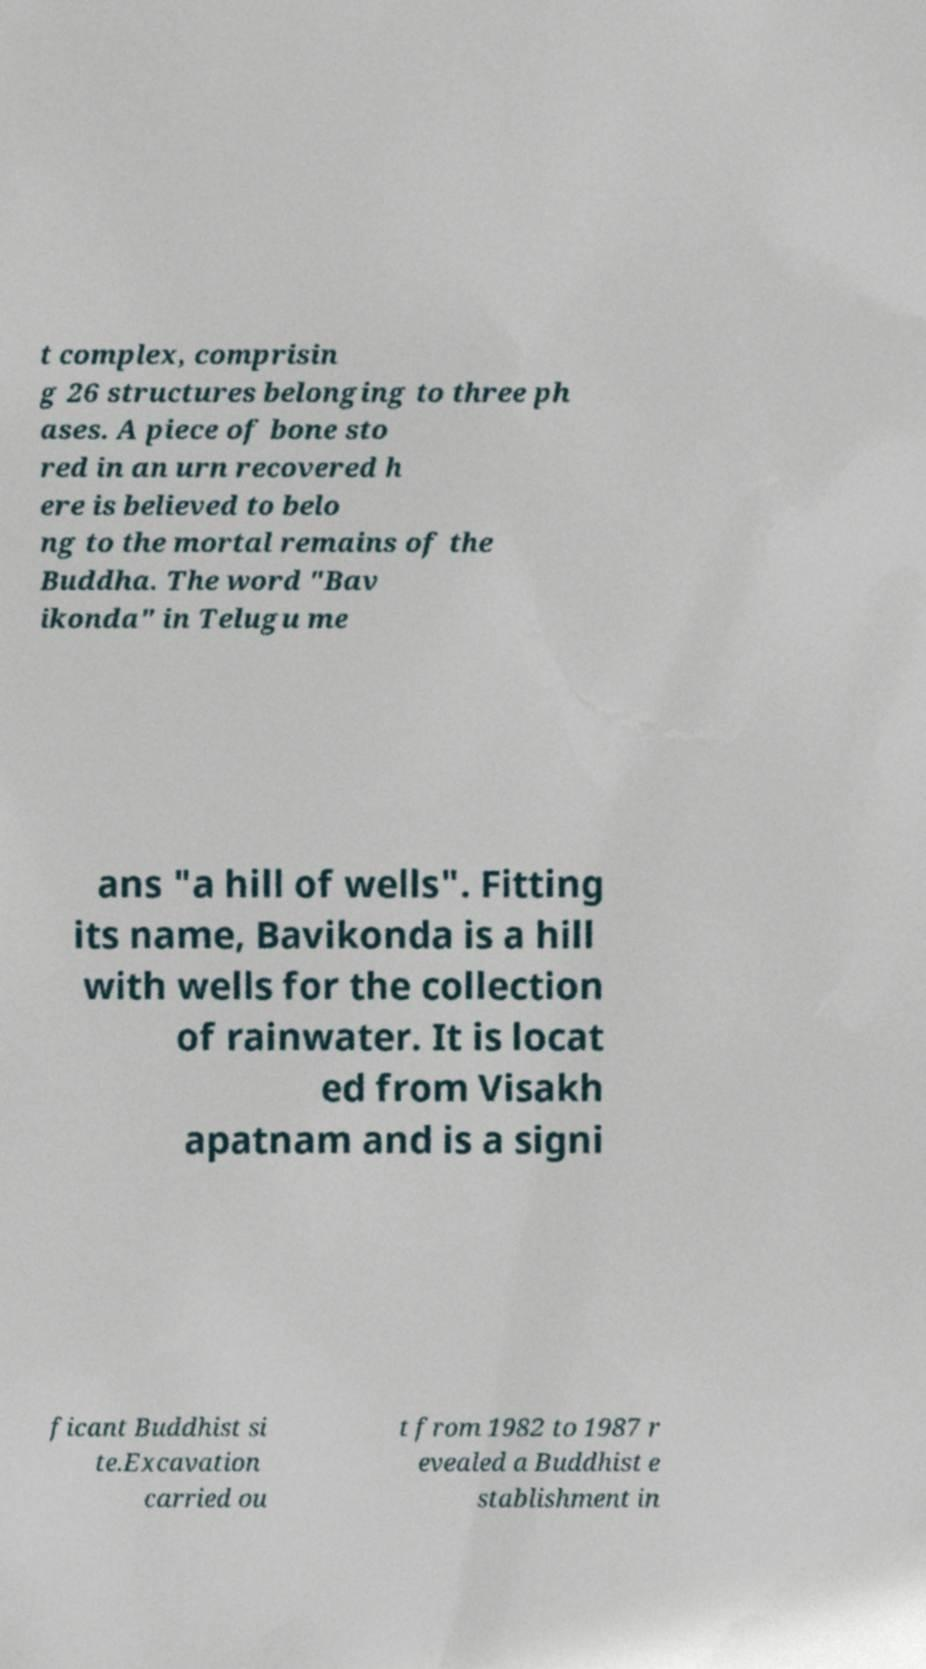There's text embedded in this image that I need extracted. Can you transcribe it verbatim? t complex, comprisin g 26 structures belonging to three ph ases. A piece of bone sto red in an urn recovered h ere is believed to belo ng to the mortal remains of the Buddha. The word "Bav ikonda" in Telugu me ans "a hill of wells". Fitting its name, Bavikonda is a hill with wells for the collection of rainwater. It is locat ed from Visakh apatnam and is a signi ficant Buddhist si te.Excavation carried ou t from 1982 to 1987 r evealed a Buddhist e stablishment in 